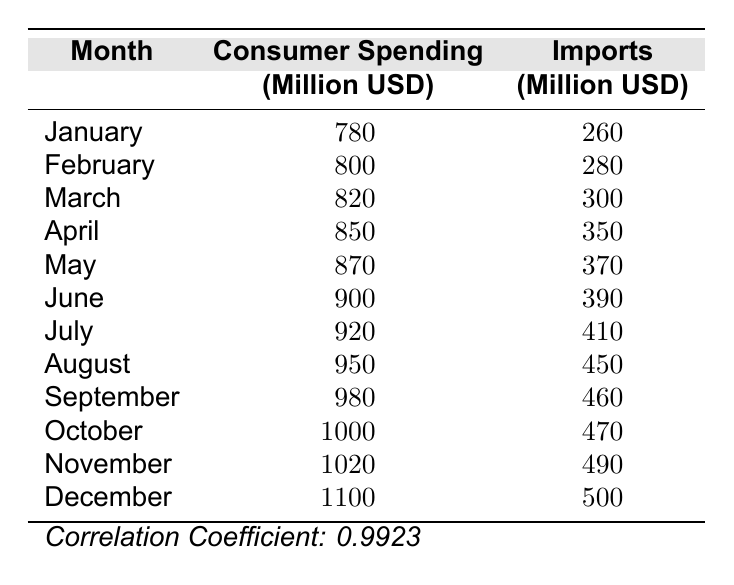What was the consumer spending in December? The table shows that in December, the consumer spending was listed as 1100 million USD.
Answer: 1100 million USD What was the total import value from January to March? To find the total import value from January to March, we sum the imports for those months: 260 (January) + 280 (February) + 300 (March) = 840 million USD.
Answer: 840 million USD Did consumer spending increase every month in 2022? Every month's data shows an increase sequentially from January to December, so the answer is yes.
Answer: Yes What was the difference between consumer spending in June and October? The consumer spending in June was 900 million USD, and in October it was 1000 million USD. The difference is 1000 - 900 = 100 million USD.
Answer: 100 million USD What was the average import value in the second quarter (April to June)? The import values for April, May, and June are 350, 370, and 390 million USD respectively. The average is (350 + 370 + 390) / 3 = 370 million USD.
Answer: 370 million USD What was the highest level of imports recorded in a month? The table indicates that the highest level of imports was in December, with a value of 500 million USD.
Answer: 500 million USD Was the correlation coefficient between consumer spending and imports in 2022 high? The table provides a correlation coefficient of 0.9923, which is indeed considered a high correlation.
Answer: Yes What was the increase in consumer spending from August to September? In August, consumer spending was 950 million USD and in September it was 980 million USD. The increase is 980 - 950 = 30 million USD.
Answer: 30 million USD What months had imports greater than 400 million USD? Looking at the table, the months where imports exceeded 400 million USD are July (410), August (450), September (460), October (470), November (490), and December (500).
Answer: July, August, September, October, November, December 